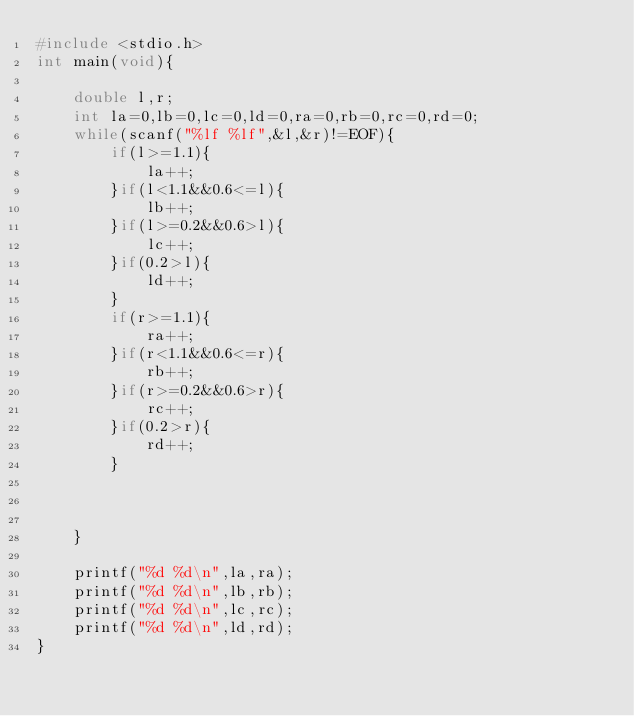<code> <loc_0><loc_0><loc_500><loc_500><_C_>#include <stdio.h>
int main(void){
    
    double l,r;
    int la=0,lb=0,lc=0,ld=0,ra=0,rb=0,rc=0,rd=0;
    while(scanf("%lf %lf",&l,&r)!=EOF){
        if(l>=1.1){
            la++;
        }if(l<1.1&&0.6<=l){
            lb++;
        }if(l>=0.2&&0.6>l){
            lc++;
        }if(0.2>l){
            ld++;
        }
        if(r>=1.1){
            ra++;
        }if(r<1.1&&0.6<=r){
            rb++;
        }if(r>=0.2&&0.6>r){
            rc++;
        }if(0.2>r){
            rd++;
        }        
        
        
        
    }   
    
    printf("%d %d\n",la,ra);
    printf("%d %d\n",lb,rb);
    printf("%d %d\n",lc,rc);
    printf("%d %d\n",ld,rd);
}
</code> 